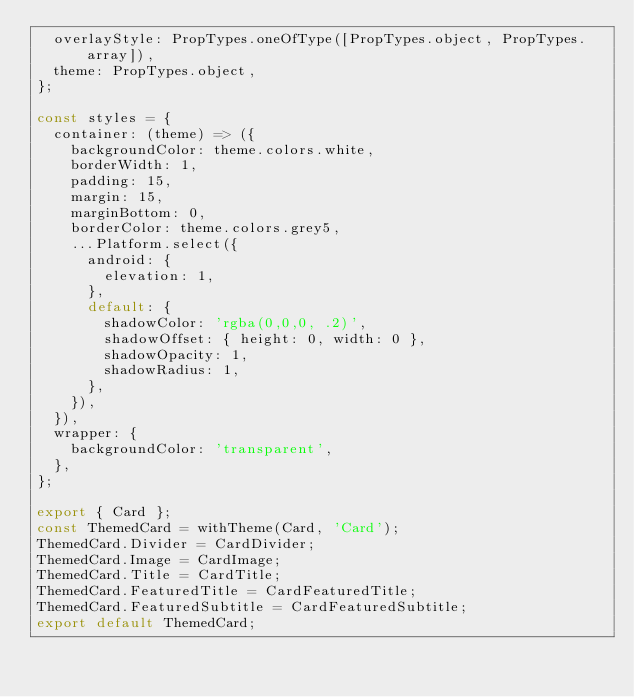Convert code to text. <code><loc_0><loc_0><loc_500><loc_500><_JavaScript_>  overlayStyle: PropTypes.oneOfType([PropTypes.object, PropTypes.array]),
  theme: PropTypes.object,
};

const styles = {
  container: (theme) => ({
    backgroundColor: theme.colors.white,
    borderWidth: 1,
    padding: 15,
    margin: 15,
    marginBottom: 0,
    borderColor: theme.colors.grey5,
    ...Platform.select({
      android: {
        elevation: 1,
      },
      default: {
        shadowColor: 'rgba(0,0,0, .2)',
        shadowOffset: { height: 0, width: 0 },
        shadowOpacity: 1,
        shadowRadius: 1,
      },
    }),
  }),
  wrapper: {
    backgroundColor: 'transparent',
  },
};

export { Card };
const ThemedCard = withTheme(Card, 'Card');
ThemedCard.Divider = CardDivider;
ThemedCard.Image = CardImage;
ThemedCard.Title = CardTitle;
ThemedCard.FeaturedTitle = CardFeaturedTitle;
ThemedCard.FeaturedSubtitle = CardFeaturedSubtitle;
export default ThemedCard;
</code> 